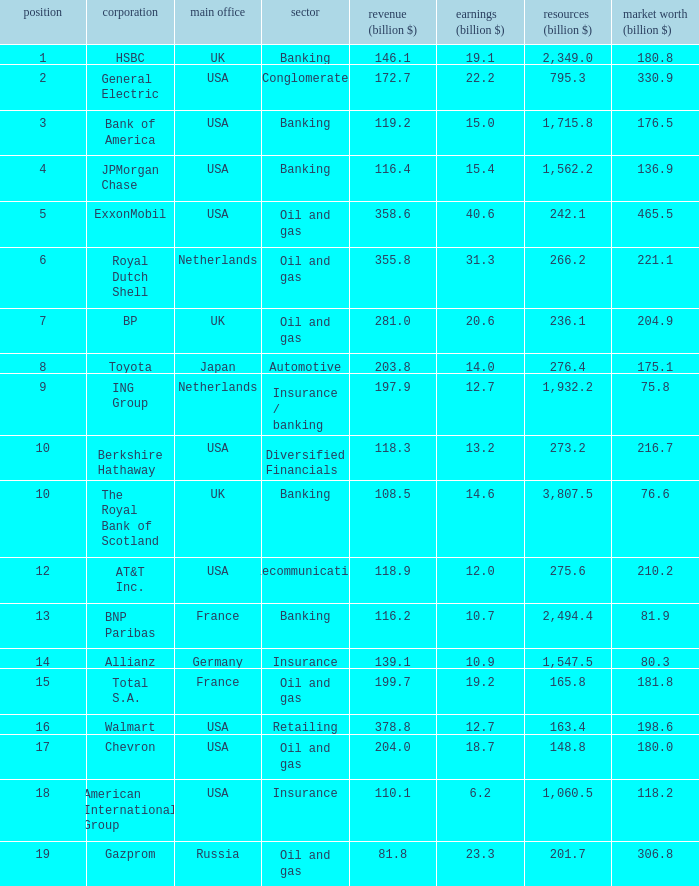What is the highest rank of a company that has 1,715.8 billion in assets?  3.0. 